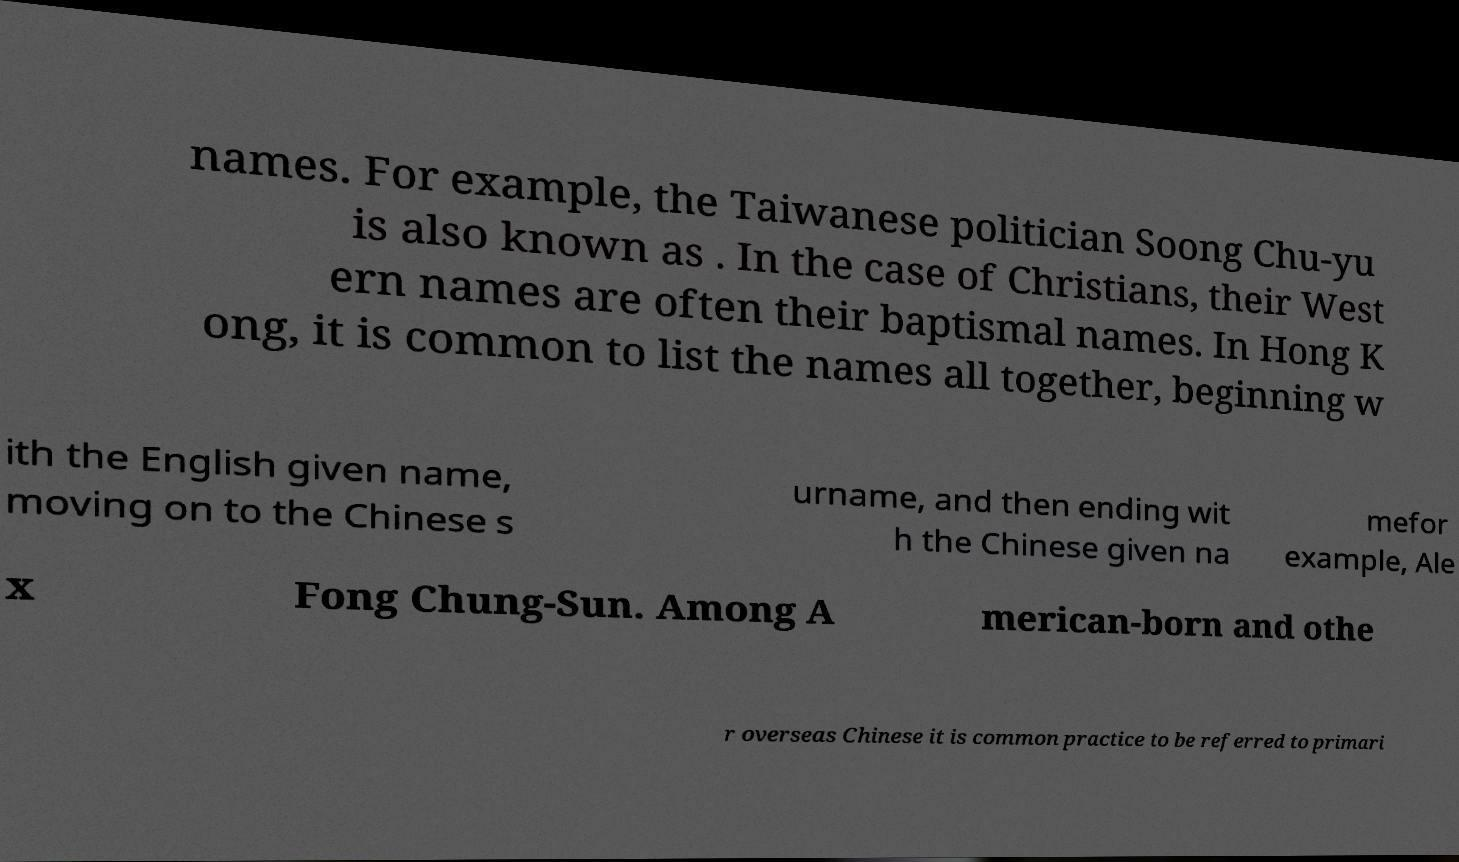I need the written content from this picture converted into text. Can you do that? names. For example, the Taiwanese politician Soong Chu-yu is also known as . In the case of Christians, their West ern names are often their baptismal names. In Hong K ong, it is common to list the names all together, beginning w ith the English given name, moving on to the Chinese s urname, and then ending wit h the Chinese given na mefor example, Ale x Fong Chung-Sun. Among A merican-born and othe r overseas Chinese it is common practice to be referred to primari 